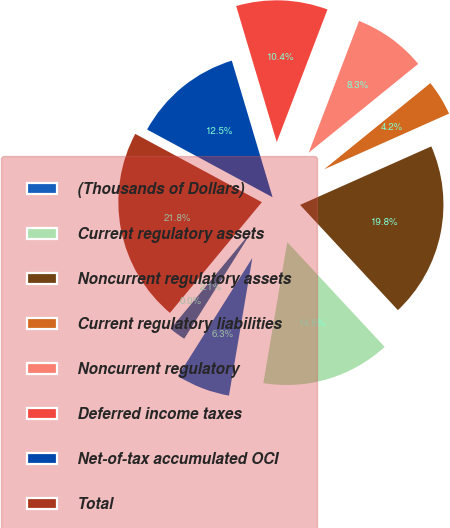Convert chart to OTSL. <chart><loc_0><loc_0><loc_500><loc_500><pie_chart><fcel>(Thousands of Dollars)<fcel>Current regulatory assets<fcel>Noncurrent regulatory assets<fcel>Current regulatory liabilities<fcel>Noncurrent regulatory<fcel>Deferred income taxes<fcel>Net-of-tax accumulated OCI<fcel>Total<fcel>Discount rate for year-end<fcel>Health care costs trend rate -<nl><fcel>6.26%<fcel>14.6%<fcel>19.76%<fcel>4.17%<fcel>8.34%<fcel>10.43%<fcel>12.51%<fcel>21.85%<fcel>0.0%<fcel>2.09%<nl></chart> 